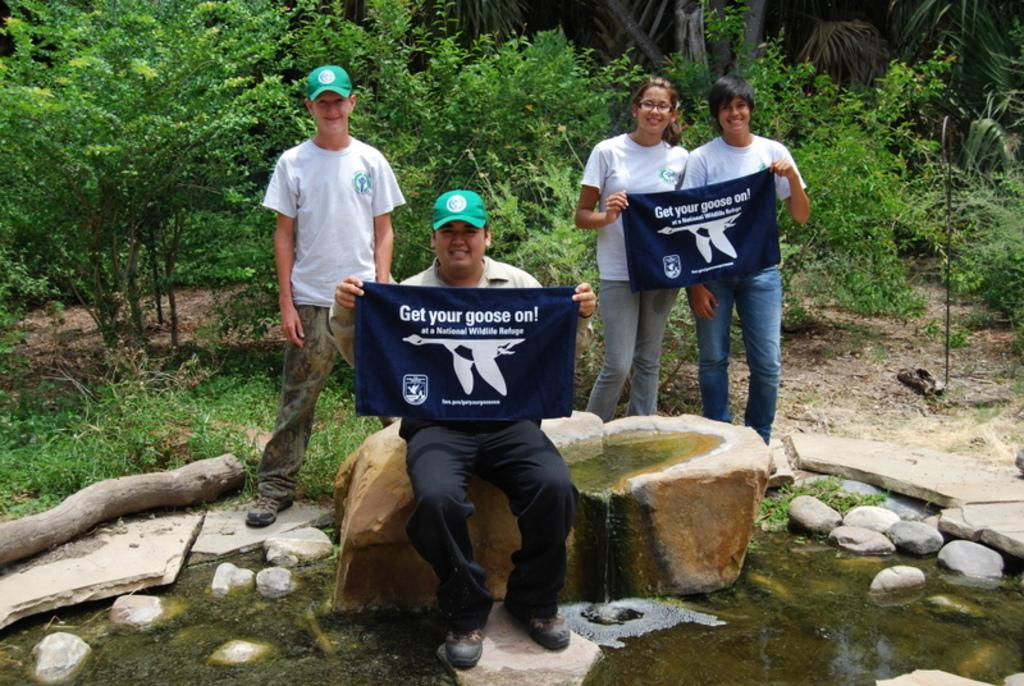<image>
Share a concise interpretation of the image provided. A group of people standing in nature with flags that refer to a wildlife refuge. 